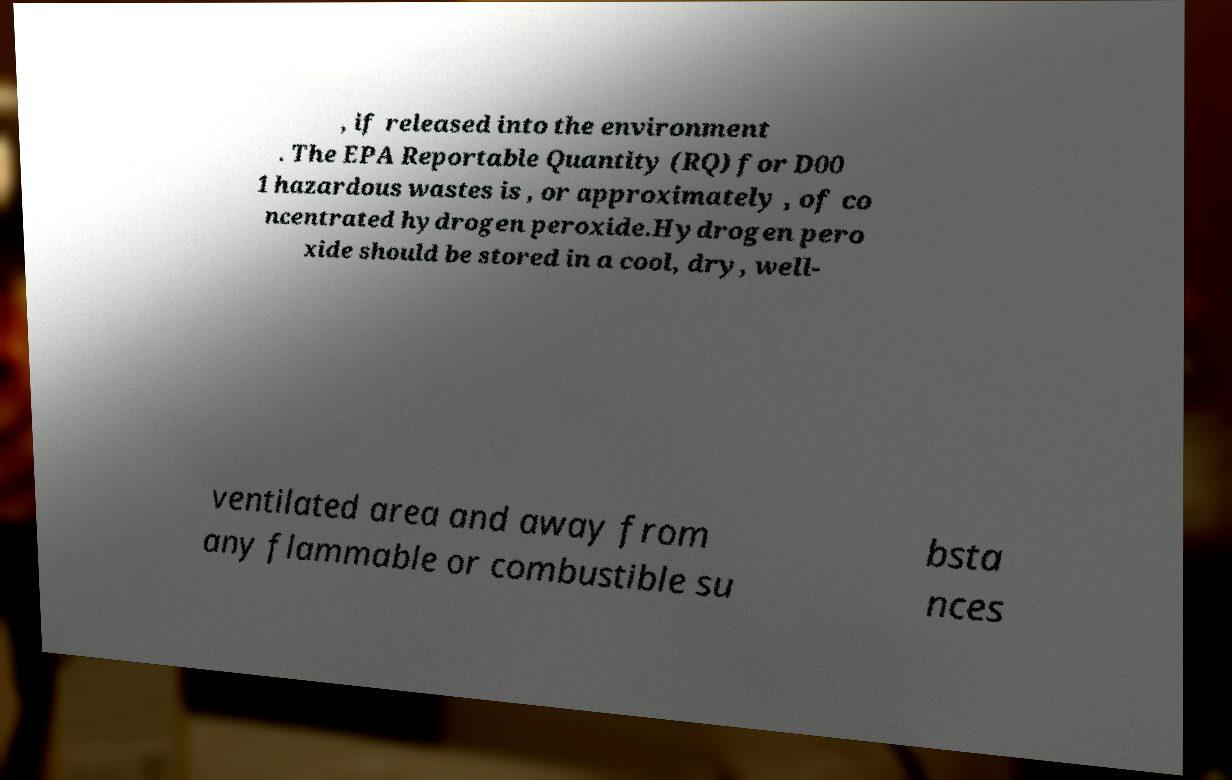Can you accurately transcribe the text from the provided image for me? , if released into the environment . The EPA Reportable Quantity (RQ) for D00 1 hazardous wastes is , or approximately , of co ncentrated hydrogen peroxide.Hydrogen pero xide should be stored in a cool, dry, well- ventilated area and away from any flammable or combustible su bsta nces 